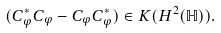<formula> <loc_0><loc_0><loc_500><loc_500>( C _ { \varphi } ^ { * } C _ { \varphi } - C _ { \varphi } C _ { \varphi } ^ { * } ) \in K ( H ^ { 2 } ( \mathbb { H } ) ) .</formula> 